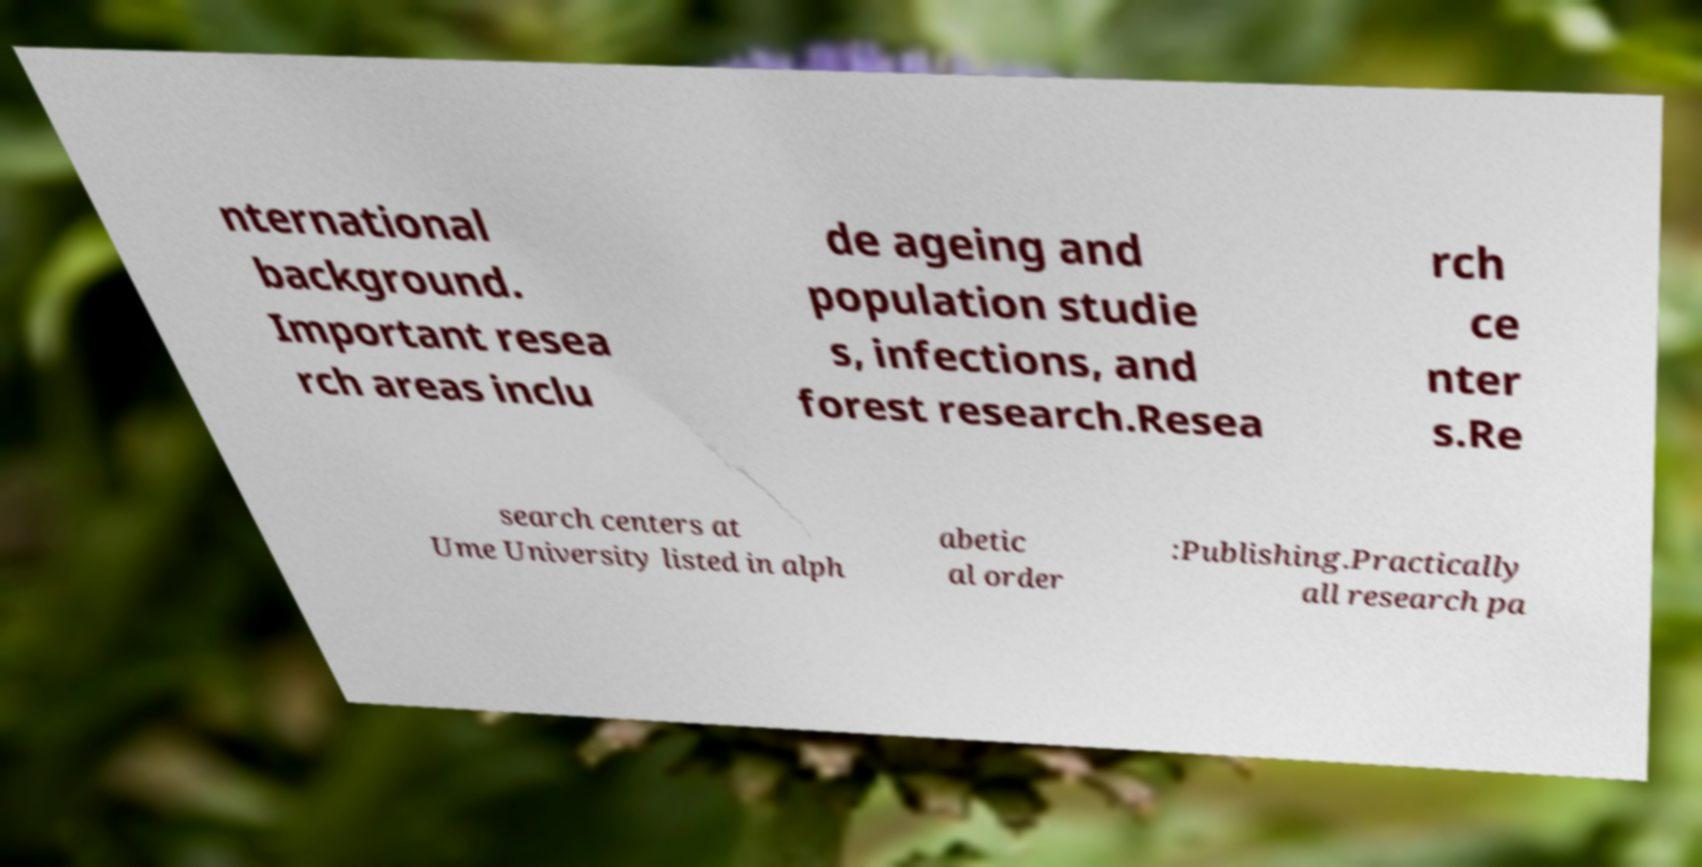What messages or text are displayed in this image? I need them in a readable, typed format. nternational background. Important resea rch areas inclu de ageing and population studie s, infections, and forest research.Resea rch ce nter s.Re search centers at Ume University listed in alph abetic al order :Publishing.Practically all research pa 